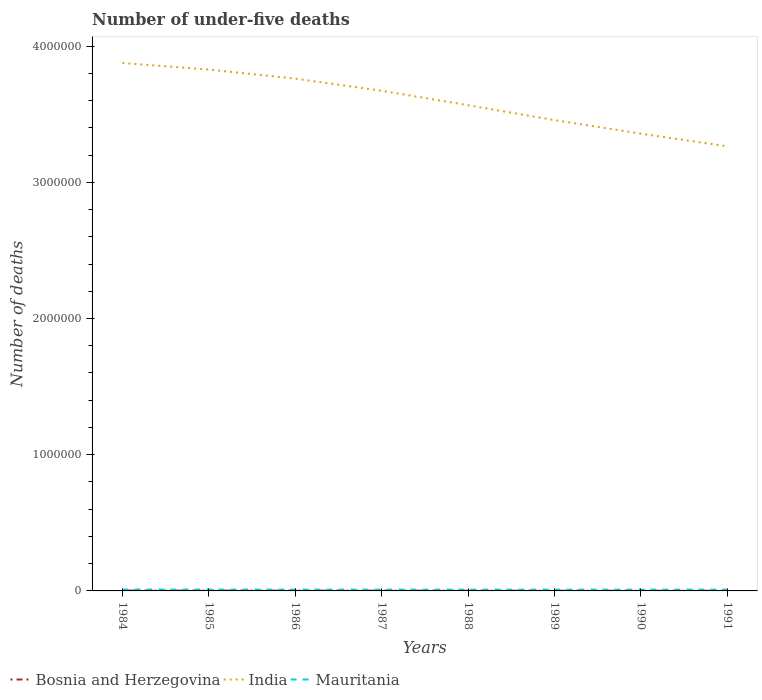Does the line corresponding to India intersect with the line corresponding to Mauritania?
Your response must be concise. No. Across all years, what is the maximum number of under-five deaths in Mauritania?
Your response must be concise. 9262. In which year was the number of under-five deaths in Mauritania maximum?
Provide a succinct answer. 1989. What is the total number of under-five deaths in Mauritania in the graph?
Give a very brief answer. 540. What is the difference between the highest and the second highest number of under-five deaths in India?
Provide a short and direct response. 6.12e+05. How many lines are there?
Give a very brief answer. 3. How are the legend labels stacked?
Your answer should be very brief. Horizontal. What is the title of the graph?
Offer a very short reply. Number of under-five deaths. Does "World" appear as one of the legend labels in the graph?
Offer a terse response. No. What is the label or title of the Y-axis?
Your answer should be compact. Number of deaths. What is the Number of deaths of Bosnia and Herzegovina in 1984?
Your answer should be compact. 2484. What is the Number of deaths in India in 1984?
Offer a terse response. 3.88e+06. What is the Number of deaths in Mauritania in 1984?
Ensure brevity in your answer.  9888. What is the Number of deaths of Bosnia and Herzegovina in 1985?
Provide a short and direct response. 2337. What is the Number of deaths of India in 1985?
Offer a terse response. 3.83e+06. What is the Number of deaths of Mauritania in 1985?
Ensure brevity in your answer.  9709. What is the Number of deaths of Bosnia and Herzegovina in 1986?
Make the answer very short. 2142. What is the Number of deaths in India in 1986?
Make the answer very short. 3.76e+06. What is the Number of deaths of Mauritania in 1986?
Provide a succinct answer. 9546. What is the Number of deaths in Bosnia and Herzegovina in 1987?
Ensure brevity in your answer.  1910. What is the Number of deaths in India in 1987?
Offer a terse response. 3.67e+06. What is the Number of deaths in Mauritania in 1987?
Offer a very short reply. 9403. What is the Number of deaths in Bosnia and Herzegovina in 1988?
Your answer should be compact. 1654. What is the Number of deaths of India in 1988?
Your response must be concise. 3.57e+06. What is the Number of deaths of Mauritania in 1988?
Keep it short and to the point. 9310. What is the Number of deaths in Bosnia and Herzegovina in 1989?
Provide a short and direct response. 1415. What is the Number of deaths of India in 1989?
Provide a short and direct response. 3.46e+06. What is the Number of deaths of Mauritania in 1989?
Provide a succinct answer. 9262. What is the Number of deaths of Bosnia and Herzegovina in 1990?
Give a very brief answer. 1194. What is the Number of deaths of India in 1990?
Make the answer very short. 3.36e+06. What is the Number of deaths in Mauritania in 1990?
Your answer should be very brief. 9285. What is the Number of deaths of Bosnia and Herzegovina in 1991?
Ensure brevity in your answer.  1020. What is the Number of deaths in India in 1991?
Offer a very short reply. 3.26e+06. What is the Number of deaths in Mauritania in 1991?
Your response must be concise. 9348. Across all years, what is the maximum Number of deaths in Bosnia and Herzegovina?
Provide a succinct answer. 2484. Across all years, what is the maximum Number of deaths in India?
Your answer should be very brief. 3.88e+06. Across all years, what is the maximum Number of deaths of Mauritania?
Your response must be concise. 9888. Across all years, what is the minimum Number of deaths in Bosnia and Herzegovina?
Keep it short and to the point. 1020. Across all years, what is the minimum Number of deaths of India?
Your response must be concise. 3.26e+06. Across all years, what is the minimum Number of deaths in Mauritania?
Ensure brevity in your answer.  9262. What is the total Number of deaths in Bosnia and Herzegovina in the graph?
Ensure brevity in your answer.  1.42e+04. What is the total Number of deaths in India in the graph?
Provide a succinct answer. 2.88e+07. What is the total Number of deaths of Mauritania in the graph?
Ensure brevity in your answer.  7.58e+04. What is the difference between the Number of deaths in Bosnia and Herzegovina in 1984 and that in 1985?
Your answer should be very brief. 147. What is the difference between the Number of deaths of India in 1984 and that in 1985?
Offer a very short reply. 4.86e+04. What is the difference between the Number of deaths in Mauritania in 1984 and that in 1985?
Ensure brevity in your answer.  179. What is the difference between the Number of deaths in Bosnia and Herzegovina in 1984 and that in 1986?
Make the answer very short. 342. What is the difference between the Number of deaths in India in 1984 and that in 1986?
Provide a short and direct response. 1.15e+05. What is the difference between the Number of deaths of Mauritania in 1984 and that in 1986?
Offer a terse response. 342. What is the difference between the Number of deaths in Bosnia and Herzegovina in 1984 and that in 1987?
Offer a very short reply. 574. What is the difference between the Number of deaths of India in 1984 and that in 1987?
Your answer should be very brief. 2.04e+05. What is the difference between the Number of deaths of Mauritania in 1984 and that in 1987?
Ensure brevity in your answer.  485. What is the difference between the Number of deaths of Bosnia and Herzegovina in 1984 and that in 1988?
Offer a terse response. 830. What is the difference between the Number of deaths of India in 1984 and that in 1988?
Ensure brevity in your answer.  3.10e+05. What is the difference between the Number of deaths in Mauritania in 1984 and that in 1988?
Your answer should be compact. 578. What is the difference between the Number of deaths in Bosnia and Herzegovina in 1984 and that in 1989?
Keep it short and to the point. 1069. What is the difference between the Number of deaths in India in 1984 and that in 1989?
Make the answer very short. 4.20e+05. What is the difference between the Number of deaths in Mauritania in 1984 and that in 1989?
Keep it short and to the point. 626. What is the difference between the Number of deaths in Bosnia and Herzegovina in 1984 and that in 1990?
Keep it short and to the point. 1290. What is the difference between the Number of deaths in India in 1984 and that in 1990?
Your response must be concise. 5.19e+05. What is the difference between the Number of deaths in Mauritania in 1984 and that in 1990?
Keep it short and to the point. 603. What is the difference between the Number of deaths in Bosnia and Herzegovina in 1984 and that in 1991?
Your answer should be very brief. 1464. What is the difference between the Number of deaths in India in 1984 and that in 1991?
Ensure brevity in your answer.  6.12e+05. What is the difference between the Number of deaths in Mauritania in 1984 and that in 1991?
Keep it short and to the point. 540. What is the difference between the Number of deaths in Bosnia and Herzegovina in 1985 and that in 1986?
Offer a very short reply. 195. What is the difference between the Number of deaths in India in 1985 and that in 1986?
Offer a very short reply. 6.61e+04. What is the difference between the Number of deaths in Mauritania in 1985 and that in 1986?
Make the answer very short. 163. What is the difference between the Number of deaths in Bosnia and Herzegovina in 1985 and that in 1987?
Your answer should be compact. 427. What is the difference between the Number of deaths in India in 1985 and that in 1987?
Give a very brief answer. 1.56e+05. What is the difference between the Number of deaths of Mauritania in 1985 and that in 1987?
Ensure brevity in your answer.  306. What is the difference between the Number of deaths of Bosnia and Herzegovina in 1985 and that in 1988?
Offer a terse response. 683. What is the difference between the Number of deaths of India in 1985 and that in 1988?
Make the answer very short. 2.61e+05. What is the difference between the Number of deaths of Mauritania in 1985 and that in 1988?
Offer a terse response. 399. What is the difference between the Number of deaths in Bosnia and Herzegovina in 1985 and that in 1989?
Your answer should be compact. 922. What is the difference between the Number of deaths in India in 1985 and that in 1989?
Your answer should be compact. 3.71e+05. What is the difference between the Number of deaths in Mauritania in 1985 and that in 1989?
Your response must be concise. 447. What is the difference between the Number of deaths of Bosnia and Herzegovina in 1985 and that in 1990?
Provide a short and direct response. 1143. What is the difference between the Number of deaths of India in 1985 and that in 1990?
Keep it short and to the point. 4.70e+05. What is the difference between the Number of deaths in Mauritania in 1985 and that in 1990?
Your response must be concise. 424. What is the difference between the Number of deaths in Bosnia and Herzegovina in 1985 and that in 1991?
Provide a short and direct response. 1317. What is the difference between the Number of deaths in India in 1985 and that in 1991?
Keep it short and to the point. 5.63e+05. What is the difference between the Number of deaths of Mauritania in 1985 and that in 1991?
Keep it short and to the point. 361. What is the difference between the Number of deaths of Bosnia and Herzegovina in 1986 and that in 1987?
Offer a very short reply. 232. What is the difference between the Number of deaths of India in 1986 and that in 1987?
Make the answer very short. 8.95e+04. What is the difference between the Number of deaths of Mauritania in 1986 and that in 1987?
Your response must be concise. 143. What is the difference between the Number of deaths in Bosnia and Herzegovina in 1986 and that in 1988?
Provide a short and direct response. 488. What is the difference between the Number of deaths of India in 1986 and that in 1988?
Ensure brevity in your answer.  1.95e+05. What is the difference between the Number of deaths in Mauritania in 1986 and that in 1988?
Your response must be concise. 236. What is the difference between the Number of deaths of Bosnia and Herzegovina in 1986 and that in 1989?
Keep it short and to the point. 727. What is the difference between the Number of deaths in India in 1986 and that in 1989?
Offer a very short reply. 3.05e+05. What is the difference between the Number of deaths in Mauritania in 1986 and that in 1989?
Offer a terse response. 284. What is the difference between the Number of deaths of Bosnia and Herzegovina in 1986 and that in 1990?
Your answer should be compact. 948. What is the difference between the Number of deaths in India in 1986 and that in 1990?
Your answer should be very brief. 4.04e+05. What is the difference between the Number of deaths of Mauritania in 1986 and that in 1990?
Your response must be concise. 261. What is the difference between the Number of deaths in Bosnia and Herzegovina in 1986 and that in 1991?
Offer a very short reply. 1122. What is the difference between the Number of deaths of India in 1986 and that in 1991?
Ensure brevity in your answer.  4.97e+05. What is the difference between the Number of deaths of Mauritania in 1986 and that in 1991?
Give a very brief answer. 198. What is the difference between the Number of deaths of Bosnia and Herzegovina in 1987 and that in 1988?
Provide a succinct answer. 256. What is the difference between the Number of deaths of India in 1987 and that in 1988?
Make the answer very short. 1.06e+05. What is the difference between the Number of deaths in Mauritania in 1987 and that in 1988?
Your response must be concise. 93. What is the difference between the Number of deaths of Bosnia and Herzegovina in 1987 and that in 1989?
Ensure brevity in your answer.  495. What is the difference between the Number of deaths of India in 1987 and that in 1989?
Offer a terse response. 2.16e+05. What is the difference between the Number of deaths of Mauritania in 1987 and that in 1989?
Make the answer very short. 141. What is the difference between the Number of deaths of Bosnia and Herzegovina in 1987 and that in 1990?
Your answer should be compact. 716. What is the difference between the Number of deaths of India in 1987 and that in 1990?
Give a very brief answer. 3.15e+05. What is the difference between the Number of deaths in Mauritania in 1987 and that in 1990?
Provide a succinct answer. 118. What is the difference between the Number of deaths in Bosnia and Herzegovina in 1987 and that in 1991?
Ensure brevity in your answer.  890. What is the difference between the Number of deaths in India in 1987 and that in 1991?
Your answer should be compact. 4.08e+05. What is the difference between the Number of deaths of Bosnia and Herzegovina in 1988 and that in 1989?
Your answer should be very brief. 239. What is the difference between the Number of deaths in India in 1988 and that in 1989?
Keep it short and to the point. 1.10e+05. What is the difference between the Number of deaths of Bosnia and Herzegovina in 1988 and that in 1990?
Your answer should be compact. 460. What is the difference between the Number of deaths in India in 1988 and that in 1990?
Make the answer very short. 2.09e+05. What is the difference between the Number of deaths of Bosnia and Herzegovina in 1988 and that in 1991?
Provide a short and direct response. 634. What is the difference between the Number of deaths of India in 1988 and that in 1991?
Offer a very short reply. 3.02e+05. What is the difference between the Number of deaths in Mauritania in 1988 and that in 1991?
Offer a terse response. -38. What is the difference between the Number of deaths of Bosnia and Herzegovina in 1989 and that in 1990?
Make the answer very short. 221. What is the difference between the Number of deaths in India in 1989 and that in 1990?
Provide a succinct answer. 9.92e+04. What is the difference between the Number of deaths of Mauritania in 1989 and that in 1990?
Give a very brief answer. -23. What is the difference between the Number of deaths in Bosnia and Herzegovina in 1989 and that in 1991?
Your answer should be very brief. 395. What is the difference between the Number of deaths of India in 1989 and that in 1991?
Offer a very short reply. 1.92e+05. What is the difference between the Number of deaths of Mauritania in 1989 and that in 1991?
Keep it short and to the point. -86. What is the difference between the Number of deaths of Bosnia and Herzegovina in 1990 and that in 1991?
Your response must be concise. 174. What is the difference between the Number of deaths of India in 1990 and that in 1991?
Offer a very short reply. 9.31e+04. What is the difference between the Number of deaths of Mauritania in 1990 and that in 1991?
Give a very brief answer. -63. What is the difference between the Number of deaths of Bosnia and Herzegovina in 1984 and the Number of deaths of India in 1985?
Your response must be concise. -3.83e+06. What is the difference between the Number of deaths in Bosnia and Herzegovina in 1984 and the Number of deaths in Mauritania in 1985?
Your answer should be very brief. -7225. What is the difference between the Number of deaths of India in 1984 and the Number of deaths of Mauritania in 1985?
Give a very brief answer. 3.87e+06. What is the difference between the Number of deaths of Bosnia and Herzegovina in 1984 and the Number of deaths of India in 1986?
Offer a terse response. -3.76e+06. What is the difference between the Number of deaths of Bosnia and Herzegovina in 1984 and the Number of deaths of Mauritania in 1986?
Keep it short and to the point. -7062. What is the difference between the Number of deaths of India in 1984 and the Number of deaths of Mauritania in 1986?
Give a very brief answer. 3.87e+06. What is the difference between the Number of deaths in Bosnia and Herzegovina in 1984 and the Number of deaths in India in 1987?
Your answer should be compact. -3.67e+06. What is the difference between the Number of deaths in Bosnia and Herzegovina in 1984 and the Number of deaths in Mauritania in 1987?
Your answer should be very brief. -6919. What is the difference between the Number of deaths of India in 1984 and the Number of deaths of Mauritania in 1987?
Your answer should be very brief. 3.87e+06. What is the difference between the Number of deaths in Bosnia and Herzegovina in 1984 and the Number of deaths in India in 1988?
Your answer should be compact. -3.56e+06. What is the difference between the Number of deaths of Bosnia and Herzegovina in 1984 and the Number of deaths of Mauritania in 1988?
Your response must be concise. -6826. What is the difference between the Number of deaths in India in 1984 and the Number of deaths in Mauritania in 1988?
Your response must be concise. 3.87e+06. What is the difference between the Number of deaths of Bosnia and Herzegovina in 1984 and the Number of deaths of India in 1989?
Offer a very short reply. -3.45e+06. What is the difference between the Number of deaths of Bosnia and Herzegovina in 1984 and the Number of deaths of Mauritania in 1989?
Your answer should be very brief. -6778. What is the difference between the Number of deaths of India in 1984 and the Number of deaths of Mauritania in 1989?
Give a very brief answer. 3.87e+06. What is the difference between the Number of deaths in Bosnia and Herzegovina in 1984 and the Number of deaths in India in 1990?
Ensure brevity in your answer.  -3.35e+06. What is the difference between the Number of deaths in Bosnia and Herzegovina in 1984 and the Number of deaths in Mauritania in 1990?
Keep it short and to the point. -6801. What is the difference between the Number of deaths in India in 1984 and the Number of deaths in Mauritania in 1990?
Your response must be concise. 3.87e+06. What is the difference between the Number of deaths in Bosnia and Herzegovina in 1984 and the Number of deaths in India in 1991?
Keep it short and to the point. -3.26e+06. What is the difference between the Number of deaths in Bosnia and Herzegovina in 1984 and the Number of deaths in Mauritania in 1991?
Provide a short and direct response. -6864. What is the difference between the Number of deaths of India in 1984 and the Number of deaths of Mauritania in 1991?
Your response must be concise. 3.87e+06. What is the difference between the Number of deaths in Bosnia and Herzegovina in 1985 and the Number of deaths in India in 1986?
Offer a terse response. -3.76e+06. What is the difference between the Number of deaths in Bosnia and Herzegovina in 1985 and the Number of deaths in Mauritania in 1986?
Offer a very short reply. -7209. What is the difference between the Number of deaths in India in 1985 and the Number of deaths in Mauritania in 1986?
Offer a terse response. 3.82e+06. What is the difference between the Number of deaths of Bosnia and Herzegovina in 1985 and the Number of deaths of India in 1987?
Provide a succinct answer. -3.67e+06. What is the difference between the Number of deaths in Bosnia and Herzegovina in 1985 and the Number of deaths in Mauritania in 1987?
Offer a very short reply. -7066. What is the difference between the Number of deaths of India in 1985 and the Number of deaths of Mauritania in 1987?
Your answer should be compact. 3.82e+06. What is the difference between the Number of deaths in Bosnia and Herzegovina in 1985 and the Number of deaths in India in 1988?
Your answer should be very brief. -3.56e+06. What is the difference between the Number of deaths of Bosnia and Herzegovina in 1985 and the Number of deaths of Mauritania in 1988?
Your response must be concise. -6973. What is the difference between the Number of deaths of India in 1985 and the Number of deaths of Mauritania in 1988?
Offer a terse response. 3.82e+06. What is the difference between the Number of deaths of Bosnia and Herzegovina in 1985 and the Number of deaths of India in 1989?
Your answer should be very brief. -3.45e+06. What is the difference between the Number of deaths in Bosnia and Herzegovina in 1985 and the Number of deaths in Mauritania in 1989?
Give a very brief answer. -6925. What is the difference between the Number of deaths of India in 1985 and the Number of deaths of Mauritania in 1989?
Your answer should be very brief. 3.82e+06. What is the difference between the Number of deaths in Bosnia and Herzegovina in 1985 and the Number of deaths in India in 1990?
Your response must be concise. -3.35e+06. What is the difference between the Number of deaths of Bosnia and Herzegovina in 1985 and the Number of deaths of Mauritania in 1990?
Your answer should be very brief. -6948. What is the difference between the Number of deaths in India in 1985 and the Number of deaths in Mauritania in 1990?
Your answer should be very brief. 3.82e+06. What is the difference between the Number of deaths in Bosnia and Herzegovina in 1985 and the Number of deaths in India in 1991?
Ensure brevity in your answer.  -3.26e+06. What is the difference between the Number of deaths in Bosnia and Herzegovina in 1985 and the Number of deaths in Mauritania in 1991?
Provide a succinct answer. -7011. What is the difference between the Number of deaths in India in 1985 and the Number of deaths in Mauritania in 1991?
Offer a terse response. 3.82e+06. What is the difference between the Number of deaths in Bosnia and Herzegovina in 1986 and the Number of deaths in India in 1987?
Give a very brief answer. -3.67e+06. What is the difference between the Number of deaths of Bosnia and Herzegovina in 1986 and the Number of deaths of Mauritania in 1987?
Provide a short and direct response. -7261. What is the difference between the Number of deaths of India in 1986 and the Number of deaths of Mauritania in 1987?
Your answer should be very brief. 3.75e+06. What is the difference between the Number of deaths of Bosnia and Herzegovina in 1986 and the Number of deaths of India in 1988?
Your answer should be compact. -3.56e+06. What is the difference between the Number of deaths in Bosnia and Herzegovina in 1986 and the Number of deaths in Mauritania in 1988?
Provide a short and direct response. -7168. What is the difference between the Number of deaths in India in 1986 and the Number of deaths in Mauritania in 1988?
Ensure brevity in your answer.  3.75e+06. What is the difference between the Number of deaths in Bosnia and Herzegovina in 1986 and the Number of deaths in India in 1989?
Ensure brevity in your answer.  -3.45e+06. What is the difference between the Number of deaths in Bosnia and Herzegovina in 1986 and the Number of deaths in Mauritania in 1989?
Ensure brevity in your answer.  -7120. What is the difference between the Number of deaths of India in 1986 and the Number of deaths of Mauritania in 1989?
Make the answer very short. 3.75e+06. What is the difference between the Number of deaths in Bosnia and Herzegovina in 1986 and the Number of deaths in India in 1990?
Offer a terse response. -3.36e+06. What is the difference between the Number of deaths of Bosnia and Herzegovina in 1986 and the Number of deaths of Mauritania in 1990?
Your response must be concise. -7143. What is the difference between the Number of deaths of India in 1986 and the Number of deaths of Mauritania in 1990?
Offer a very short reply. 3.75e+06. What is the difference between the Number of deaths in Bosnia and Herzegovina in 1986 and the Number of deaths in India in 1991?
Provide a succinct answer. -3.26e+06. What is the difference between the Number of deaths in Bosnia and Herzegovina in 1986 and the Number of deaths in Mauritania in 1991?
Ensure brevity in your answer.  -7206. What is the difference between the Number of deaths in India in 1986 and the Number of deaths in Mauritania in 1991?
Give a very brief answer. 3.75e+06. What is the difference between the Number of deaths of Bosnia and Herzegovina in 1987 and the Number of deaths of India in 1988?
Ensure brevity in your answer.  -3.56e+06. What is the difference between the Number of deaths in Bosnia and Herzegovina in 1987 and the Number of deaths in Mauritania in 1988?
Offer a terse response. -7400. What is the difference between the Number of deaths of India in 1987 and the Number of deaths of Mauritania in 1988?
Your answer should be compact. 3.66e+06. What is the difference between the Number of deaths of Bosnia and Herzegovina in 1987 and the Number of deaths of India in 1989?
Provide a succinct answer. -3.45e+06. What is the difference between the Number of deaths in Bosnia and Herzegovina in 1987 and the Number of deaths in Mauritania in 1989?
Make the answer very short. -7352. What is the difference between the Number of deaths of India in 1987 and the Number of deaths of Mauritania in 1989?
Ensure brevity in your answer.  3.66e+06. What is the difference between the Number of deaths in Bosnia and Herzegovina in 1987 and the Number of deaths in India in 1990?
Your answer should be compact. -3.36e+06. What is the difference between the Number of deaths in Bosnia and Herzegovina in 1987 and the Number of deaths in Mauritania in 1990?
Offer a very short reply. -7375. What is the difference between the Number of deaths in India in 1987 and the Number of deaths in Mauritania in 1990?
Your response must be concise. 3.66e+06. What is the difference between the Number of deaths of Bosnia and Herzegovina in 1987 and the Number of deaths of India in 1991?
Your answer should be very brief. -3.26e+06. What is the difference between the Number of deaths of Bosnia and Herzegovina in 1987 and the Number of deaths of Mauritania in 1991?
Your response must be concise. -7438. What is the difference between the Number of deaths in India in 1987 and the Number of deaths in Mauritania in 1991?
Keep it short and to the point. 3.66e+06. What is the difference between the Number of deaths of Bosnia and Herzegovina in 1988 and the Number of deaths of India in 1989?
Make the answer very short. -3.45e+06. What is the difference between the Number of deaths of Bosnia and Herzegovina in 1988 and the Number of deaths of Mauritania in 1989?
Your response must be concise. -7608. What is the difference between the Number of deaths of India in 1988 and the Number of deaths of Mauritania in 1989?
Ensure brevity in your answer.  3.56e+06. What is the difference between the Number of deaths in Bosnia and Herzegovina in 1988 and the Number of deaths in India in 1990?
Provide a succinct answer. -3.36e+06. What is the difference between the Number of deaths in Bosnia and Herzegovina in 1988 and the Number of deaths in Mauritania in 1990?
Ensure brevity in your answer.  -7631. What is the difference between the Number of deaths of India in 1988 and the Number of deaths of Mauritania in 1990?
Your response must be concise. 3.56e+06. What is the difference between the Number of deaths of Bosnia and Herzegovina in 1988 and the Number of deaths of India in 1991?
Keep it short and to the point. -3.26e+06. What is the difference between the Number of deaths in Bosnia and Herzegovina in 1988 and the Number of deaths in Mauritania in 1991?
Ensure brevity in your answer.  -7694. What is the difference between the Number of deaths of India in 1988 and the Number of deaths of Mauritania in 1991?
Your response must be concise. 3.56e+06. What is the difference between the Number of deaths in Bosnia and Herzegovina in 1989 and the Number of deaths in India in 1990?
Your answer should be compact. -3.36e+06. What is the difference between the Number of deaths of Bosnia and Herzegovina in 1989 and the Number of deaths of Mauritania in 1990?
Ensure brevity in your answer.  -7870. What is the difference between the Number of deaths of India in 1989 and the Number of deaths of Mauritania in 1990?
Ensure brevity in your answer.  3.45e+06. What is the difference between the Number of deaths of Bosnia and Herzegovina in 1989 and the Number of deaths of India in 1991?
Keep it short and to the point. -3.26e+06. What is the difference between the Number of deaths of Bosnia and Herzegovina in 1989 and the Number of deaths of Mauritania in 1991?
Provide a short and direct response. -7933. What is the difference between the Number of deaths in India in 1989 and the Number of deaths in Mauritania in 1991?
Your answer should be very brief. 3.45e+06. What is the difference between the Number of deaths of Bosnia and Herzegovina in 1990 and the Number of deaths of India in 1991?
Your answer should be compact. -3.26e+06. What is the difference between the Number of deaths of Bosnia and Herzegovina in 1990 and the Number of deaths of Mauritania in 1991?
Your answer should be very brief. -8154. What is the difference between the Number of deaths of India in 1990 and the Number of deaths of Mauritania in 1991?
Offer a very short reply. 3.35e+06. What is the average Number of deaths of Bosnia and Herzegovina per year?
Your answer should be compact. 1769.5. What is the average Number of deaths of India per year?
Ensure brevity in your answer.  3.60e+06. What is the average Number of deaths of Mauritania per year?
Make the answer very short. 9468.88. In the year 1984, what is the difference between the Number of deaths of Bosnia and Herzegovina and Number of deaths of India?
Provide a succinct answer. -3.87e+06. In the year 1984, what is the difference between the Number of deaths of Bosnia and Herzegovina and Number of deaths of Mauritania?
Your answer should be compact. -7404. In the year 1984, what is the difference between the Number of deaths in India and Number of deaths in Mauritania?
Offer a very short reply. 3.87e+06. In the year 1985, what is the difference between the Number of deaths of Bosnia and Herzegovina and Number of deaths of India?
Your answer should be compact. -3.83e+06. In the year 1985, what is the difference between the Number of deaths of Bosnia and Herzegovina and Number of deaths of Mauritania?
Make the answer very short. -7372. In the year 1985, what is the difference between the Number of deaths of India and Number of deaths of Mauritania?
Provide a short and direct response. 3.82e+06. In the year 1986, what is the difference between the Number of deaths of Bosnia and Herzegovina and Number of deaths of India?
Provide a succinct answer. -3.76e+06. In the year 1986, what is the difference between the Number of deaths of Bosnia and Herzegovina and Number of deaths of Mauritania?
Your answer should be very brief. -7404. In the year 1986, what is the difference between the Number of deaths in India and Number of deaths in Mauritania?
Keep it short and to the point. 3.75e+06. In the year 1987, what is the difference between the Number of deaths in Bosnia and Herzegovina and Number of deaths in India?
Provide a short and direct response. -3.67e+06. In the year 1987, what is the difference between the Number of deaths of Bosnia and Herzegovina and Number of deaths of Mauritania?
Ensure brevity in your answer.  -7493. In the year 1987, what is the difference between the Number of deaths in India and Number of deaths in Mauritania?
Give a very brief answer. 3.66e+06. In the year 1988, what is the difference between the Number of deaths of Bosnia and Herzegovina and Number of deaths of India?
Your response must be concise. -3.56e+06. In the year 1988, what is the difference between the Number of deaths of Bosnia and Herzegovina and Number of deaths of Mauritania?
Your answer should be very brief. -7656. In the year 1988, what is the difference between the Number of deaths in India and Number of deaths in Mauritania?
Your answer should be very brief. 3.56e+06. In the year 1989, what is the difference between the Number of deaths in Bosnia and Herzegovina and Number of deaths in India?
Provide a short and direct response. -3.46e+06. In the year 1989, what is the difference between the Number of deaths in Bosnia and Herzegovina and Number of deaths in Mauritania?
Your answer should be compact. -7847. In the year 1989, what is the difference between the Number of deaths of India and Number of deaths of Mauritania?
Provide a succinct answer. 3.45e+06. In the year 1990, what is the difference between the Number of deaths in Bosnia and Herzegovina and Number of deaths in India?
Provide a short and direct response. -3.36e+06. In the year 1990, what is the difference between the Number of deaths in Bosnia and Herzegovina and Number of deaths in Mauritania?
Provide a short and direct response. -8091. In the year 1990, what is the difference between the Number of deaths of India and Number of deaths of Mauritania?
Ensure brevity in your answer.  3.35e+06. In the year 1991, what is the difference between the Number of deaths in Bosnia and Herzegovina and Number of deaths in India?
Offer a very short reply. -3.26e+06. In the year 1991, what is the difference between the Number of deaths in Bosnia and Herzegovina and Number of deaths in Mauritania?
Ensure brevity in your answer.  -8328. In the year 1991, what is the difference between the Number of deaths in India and Number of deaths in Mauritania?
Offer a very short reply. 3.25e+06. What is the ratio of the Number of deaths of Bosnia and Herzegovina in 1984 to that in 1985?
Ensure brevity in your answer.  1.06. What is the ratio of the Number of deaths in India in 1984 to that in 1985?
Your response must be concise. 1.01. What is the ratio of the Number of deaths in Mauritania in 1984 to that in 1985?
Offer a terse response. 1.02. What is the ratio of the Number of deaths in Bosnia and Herzegovina in 1984 to that in 1986?
Your answer should be very brief. 1.16. What is the ratio of the Number of deaths in India in 1984 to that in 1986?
Make the answer very short. 1.03. What is the ratio of the Number of deaths of Mauritania in 1984 to that in 1986?
Give a very brief answer. 1.04. What is the ratio of the Number of deaths in Bosnia and Herzegovina in 1984 to that in 1987?
Your answer should be compact. 1.3. What is the ratio of the Number of deaths of India in 1984 to that in 1987?
Provide a short and direct response. 1.06. What is the ratio of the Number of deaths of Mauritania in 1984 to that in 1987?
Offer a terse response. 1.05. What is the ratio of the Number of deaths in Bosnia and Herzegovina in 1984 to that in 1988?
Give a very brief answer. 1.5. What is the ratio of the Number of deaths of India in 1984 to that in 1988?
Give a very brief answer. 1.09. What is the ratio of the Number of deaths in Mauritania in 1984 to that in 1988?
Give a very brief answer. 1.06. What is the ratio of the Number of deaths in Bosnia and Herzegovina in 1984 to that in 1989?
Provide a short and direct response. 1.76. What is the ratio of the Number of deaths in India in 1984 to that in 1989?
Provide a short and direct response. 1.12. What is the ratio of the Number of deaths in Mauritania in 1984 to that in 1989?
Your response must be concise. 1.07. What is the ratio of the Number of deaths in Bosnia and Herzegovina in 1984 to that in 1990?
Give a very brief answer. 2.08. What is the ratio of the Number of deaths of India in 1984 to that in 1990?
Offer a very short reply. 1.15. What is the ratio of the Number of deaths in Mauritania in 1984 to that in 1990?
Offer a very short reply. 1.06. What is the ratio of the Number of deaths in Bosnia and Herzegovina in 1984 to that in 1991?
Keep it short and to the point. 2.44. What is the ratio of the Number of deaths in India in 1984 to that in 1991?
Make the answer very short. 1.19. What is the ratio of the Number of deaths of Mauritania in 1984 to that in 1991?
Offer a terse response. 1.06. What is the ratio of the Number of deaths of Bosnia and Herzegovina in 1985 to that in 1986?
Your answer should be very brief. 1.09. What is the ratio of the Number of deaths in India in 1985 to that in 1986?
Offer a terse response. 1.02. What is the ratio of the Number of deaths in Mauritania in 1985 to that in 1986?
Make the answer very short. 1.02. What is the ratio of the Number of deaths in Bosnia and Herzegovina in 1985 to that in 1987?
Ensure brevity in your answer.  1.22. What is the ratio of the Number of deaths in India in 1985 to that in 1987?
Ensure brevity in your answer.  1.04. What is the ratio of the Number of deaths of Mauritania in 1985 to that in 1987?
Provide a short and direct response. 1.03. What is the ratio of the Number of deaths in Bosnia and Herzegovina in 1985 to that in 1988?
Offer a terse response. 1.41. What is the ratio of the Number of deaths in India in 1985 to that in 1988?
Your answer should be very brief. 1.07. What is the ratio of the Number of deaths in Mauritania in 1985 to that in 1988?
Ensure brevity in your answer.  1.04. What is the ratio of the Number of deaths in Bosnia and Herzegovina in 1985 to that in 1989?
Offer a very short reply. 1.65. What is the ratio of the Number of deaths of India in 1985 to that in 1989?
Provide a short and direct response. 1.11. What is the ratio of the Number of deaths in Mauritania in 1985 to that in 1989?
Give a very brief answer. 1.05. What is the ratio of the Number of deaths of Bosnia and Herzegovina in 1985 to that in 1990?
Your answer should be very brief. 1.96. What is the ratio of the Number of deaths of India in 1985 to that in 1990?
Your answer should be compact. 1.14. What is the ratio of the Number of deaths in Mauritania in 1985 to that in 1990?
Keep it short and to the point. 1.05. What is the ratio of the Number of deaths of Bosnia and Herzegovina in 1985 to that in 1991?
Make the answer very short. 2.29. What is the ratio of the Number of deaths of India in 1985 to that in 1991?
Provide a succinct answer. 1.17. What is the ratio of the Number of deaths in Mauritania in 1985 to that in 1991?
Make the answer very short. 1.04. What is the ratio of the Number of deaths in Bosnia and Herzegovina in 1986 to that in 1987?
Provide a short and direct response. 1.12. What is the ratio of the Number of deaths in India in 1986 to that in 1987?
Ensure brevity in your answer.  1.02. What is the ratio of the Number of deaths in Mauritania in 1986 to that in 1987?
Provide a short and direct response. 1.02. What is the ratio of the Number of deaths in Bosnia and Herzegovina in 1986 to that in 1988?
Your answer should be compact. 1.29. What is the ratio of the Number of deaths in India in 1986 to that in 1988?
Offer a very short reply. 1.05. What is the ratio of the Number of deaths in Mauritania in 1986 to that in 1988?
Give a very brief answer. 1.03. What is the ratio of the Number of deaths in Bosnia and Herzegovina in 1986 to that in 1989?
Give a very brief answer. 1.51. What is the ratio of the Number of deaths in India in 1986 to that in 1989?
Your answer should be very brief. 1.09. What is the ratio of the Number of deaths in Mauritania in 1986 to that in 1989?
Your answer should be compact. 1.03. What is the ratio of the Number of deaths in Bosnia and Herzegovina in 1986 to that in 1990?
Your answer should be very brief. 1.79. What is the ratio of the Number of deaths of India in 1986 to that in 1990?
Keep it short and to the point. 1.12. What is the ratio of the Number of deaths of Mauritania in 1986 to that in 1990?
Provide a succinct answer. 1.03. What is the ratio of the Number of deaths of India in 1986 to that in 1991?
Offer a very short reply. 1.15. What is the ratio of the Number of deaths of Mauritania in 1986 to that in 1991?
Offer a very short reply. 1.02. What is the ratio of the Number of deaths of Bosnia and Herzegovina in 1987 to that in 1988?
Offer a terse response. 1.15. What is the ratio of the Number of deaths in India in 1987 to that in 1988?
Your answer should be very brief. 1.03. What is the ratio of the Number of deaths of Bosnia and Herzegovina in 1987 to that in 1989?
Your response must be concise. 1.35. What is the ratio of the Number of deaths in India in 1987 to that in 1989?
Offer a terse response. 1.06. What is the ratio of the Number of deaths in Mauritania in 1987 to that in 1989?
Your answer should be compact. 1.02. What is the ratio of the Number of deaths in Bosnia and Herzegovina in 1987 to that in 1990?
Your answer should be compact. 1.6. What is the ratio of the Number of deaths of India in 1987 to that in 1990?
Your answer should be compact. 1.09. What is the ratio of the Number of deaths of Mauritania in 1987 to that in 1990?
Your answer should be very brief. 1.01. What is the ratio of the Number of deaths of Bosnia and Herzegovina in 1987 to that in 1991?
Offer a very short reply. 1.87. What is the ratio of the Number of deaths in India in 1987 to that in 1991?
Offer a very short reply. 1.12. What is the ratio of the Number of deaths of Mauritania in 1987 to that in 1991?
Offer a terse response. 1.01. What is the ratio of the Number of deaths in Bosnia and Herzegovina in 1988 to that in 1989?
Keep it short and to the point. 1.17. What is the ratio of the Number of deaths of India in 1988 to that in 1989?
Your answer should be very brief. 1.03. What is the ratio of the Number of deaths of Bosnia and Herzegovina in 1988 to that in 1990?
Give a very brief answer. 1.39. What is the ratio of the Number of deaths in India in 1988 to that in 1990?
Your response must be concise. 1.06. What is the ratio of the Number of deaths of Bosnia and Herzegovina in 1988 to that in 1991?
Offer a terse response. 1.62. What is the ratio of the Number of deaths in India in 1988 to that in 1991?
Offer a terse response. 1.09. What is the ratio of the Number of deaths in Mauritania in 1988 to that in 1991?
Offer a very short reply. 1. What is the ratio of the Number of deaths of Bosnia and Herzegovina in 1989 to that in 1990?
Give a very brief answer. 1.19. What is the ratio of the Number of deaths of India in 1989 to that in 1990?
Your response must be concise. 1.03. What is the ratio of the Number of deaths of Bosnia and Herzegovina in 1989 to that in 1991?
Your answer should be very brief. 1.39. What is the ratio of the Number of deaths in India in 1989 to that in 1991?
Your answer should be compact. 1.06. What is the ratio of the Number of deaths in Bosnia and Herzegovina in 1990 to that in 1991?
Offer a terse response. 1.17. What is the ratio of the Number of deaths of India in 1990 to that in 1991?
Provide a succinct answer. 1.03. What is the ratio of the Number of deaths of Mauritania in 1990 to that in 1991?
Your answer should be compact. 0.99. What is the difference between the highest and the second highest Number of deaths of Bosnia and Herzegovina?
Make the answer very short. 147. What is the difference between the highest and the second highest Number of deaths of India?
Your answer should be very brief. 4.86e+04. What is the difference between the highest and the second highest Number of deaths in Mauritania?
Your answer should be compact. 179. What is the difference between the highest and the lowest Number of deaths of Bosnia and Herzegovina?
Give a very brief answer. 1464. What is the difference between the highest and the lowest Number of deaths in India?
Ensure brevity in your answer.  6.12e+05. What is the difference between the highest and the lowest Number of deaths of Mauritania?
Provide a short and direct response. 626. 